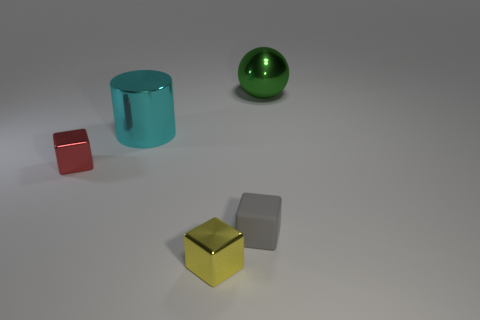Subtract all tiny shiny blocks. How many blocks are left? 1 Subtract 1 cubes. How many cubes are left? 2 Add 4 small matte blocks. How many objects exist? 9 Subtract all cubes. How many objects are left? 2 Subtract all blue blocks. Subtract all blue spheres. How many blocks are left? 3 Subtract all large gray metallic balls. Subtract all big spheres. How many objects are left? 4 Add 2 small gray objects. How many small gray objects are left? 3 Add 2 large shiny objects. How many large shiny objects exist? 4 Subtract 0 purple cylinders. How many objects are left? 5 